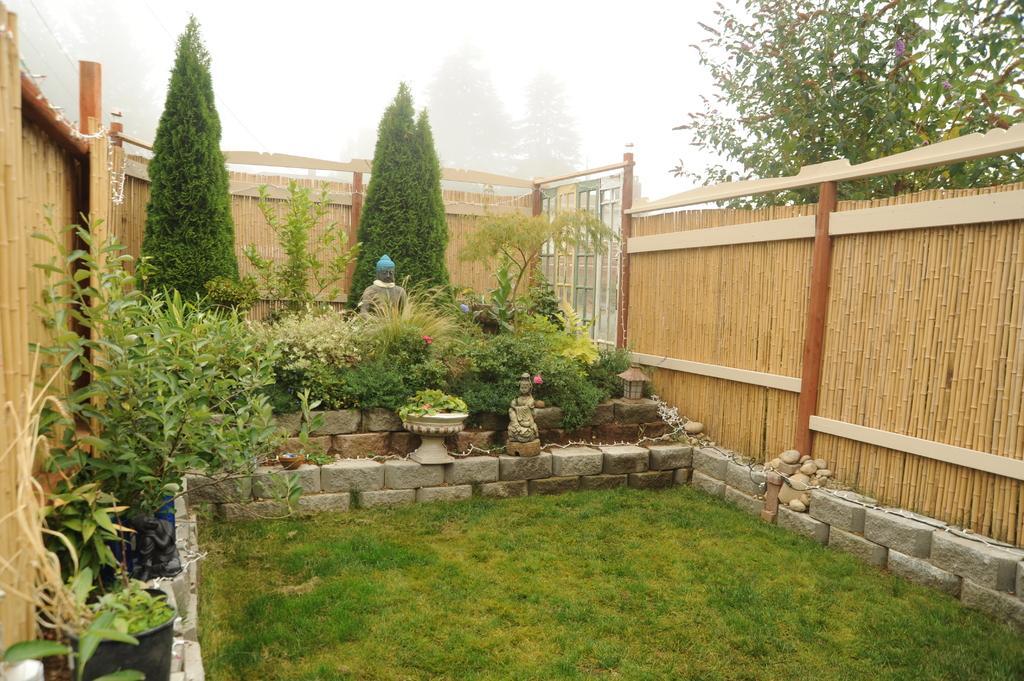Please provide a concise description of this image. There is a grass lawn. On the sides there is a brick wall. On that there is a pot with a plant. In the back there are trees and plants. There is a wooden fencing. On the right side there is a tree. In the back there is sky. 